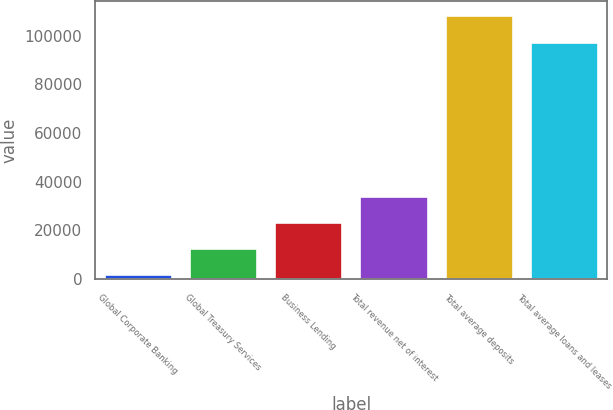<chart> <loc_0><loc_0><loc_500><loc_500><bar_chart><fcel>Global Corporate Banking<fcel>Global Treasury Services<fcel>Business Lending<fcel>Total revenue net of interest<fcel>Total average deposits<fcel>Total average loans and leases<nl><fcel>2011<fcel>12676.2<fcel>23341.4<fcel>34006.6<fcel>108663<fcel>97346<nl></chart> 